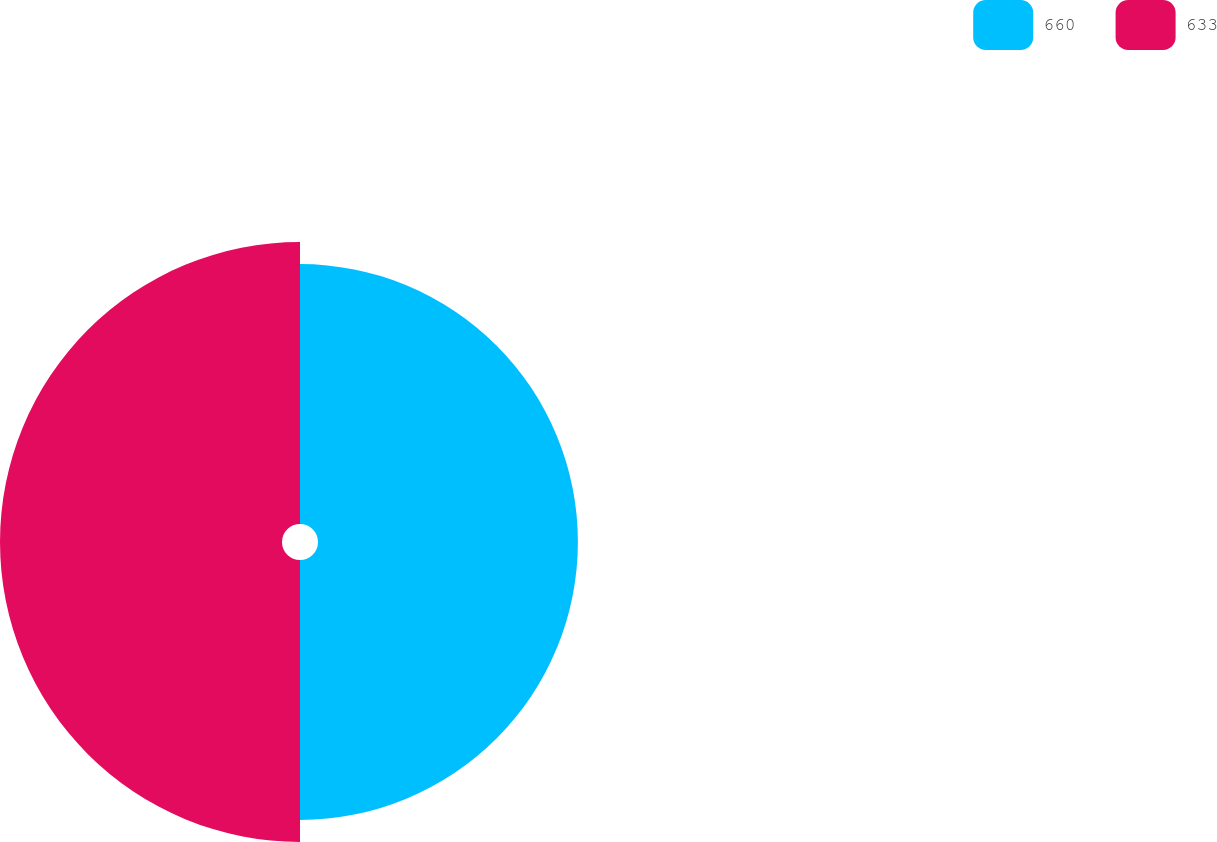Convert chart to OTSL. <chart><loc_0><loc_0><loc_500><loc_500><pie_chart><fcel>660<fcel>633<nl><fcel>47.96%<fcel>52.04%<nl></chart> 